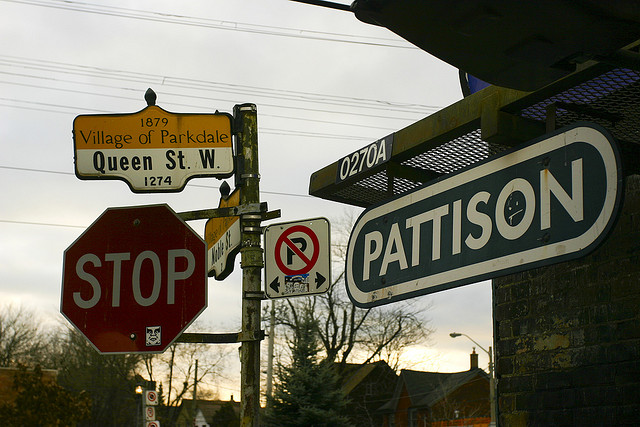Identify the text contained in this image. 070A Queen STOP PATTISON Village P st 1274 W st Parkdale of 1879 